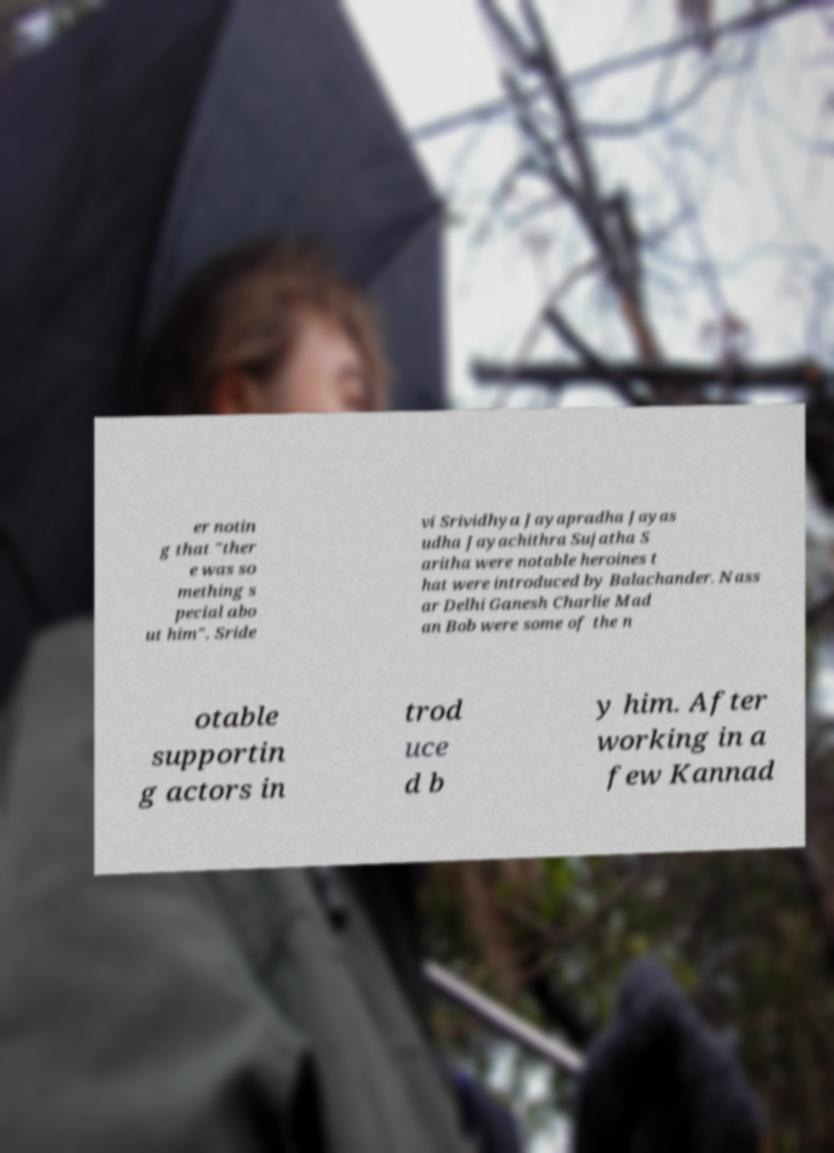For documentation purposes, I need the text within this image transcribed. Could you provide that? er notin g that "ther e was so mething s pecial abo ut him". Sride vi Srividhya Jayapradha Jayas udha Jayachithra Sujatha S aritha were notable heroines t hat were introduced by Balachander. Nass ar Delhi Ganesh Charlie Mad an Bob were some of the n otable supportin g actors in trod uce d b y him. After working in a few Kannad 